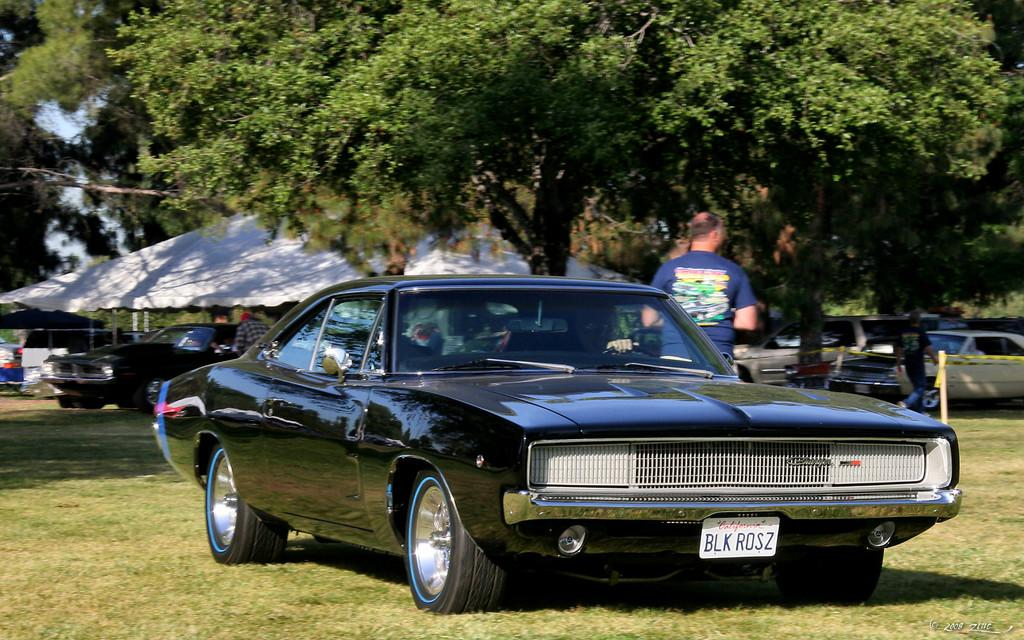What types of objects are in the image? There are vehicles and a group of people in the image. What can be seen in the background of the image? There is a tent and trees in the background of the image. What is visible at the top of the image? The sky is visible at the top of the image. What type of terrain is present at the bottom of the image? Grass is present at the bottom of the image. What type of pet can be seen playing with a cord in the image? There is no pet or cord present in the image. What type of brush is being used by the group of people in the image? There is no brush visible in the image; the group of people is not performing any activity that involves a brush. 